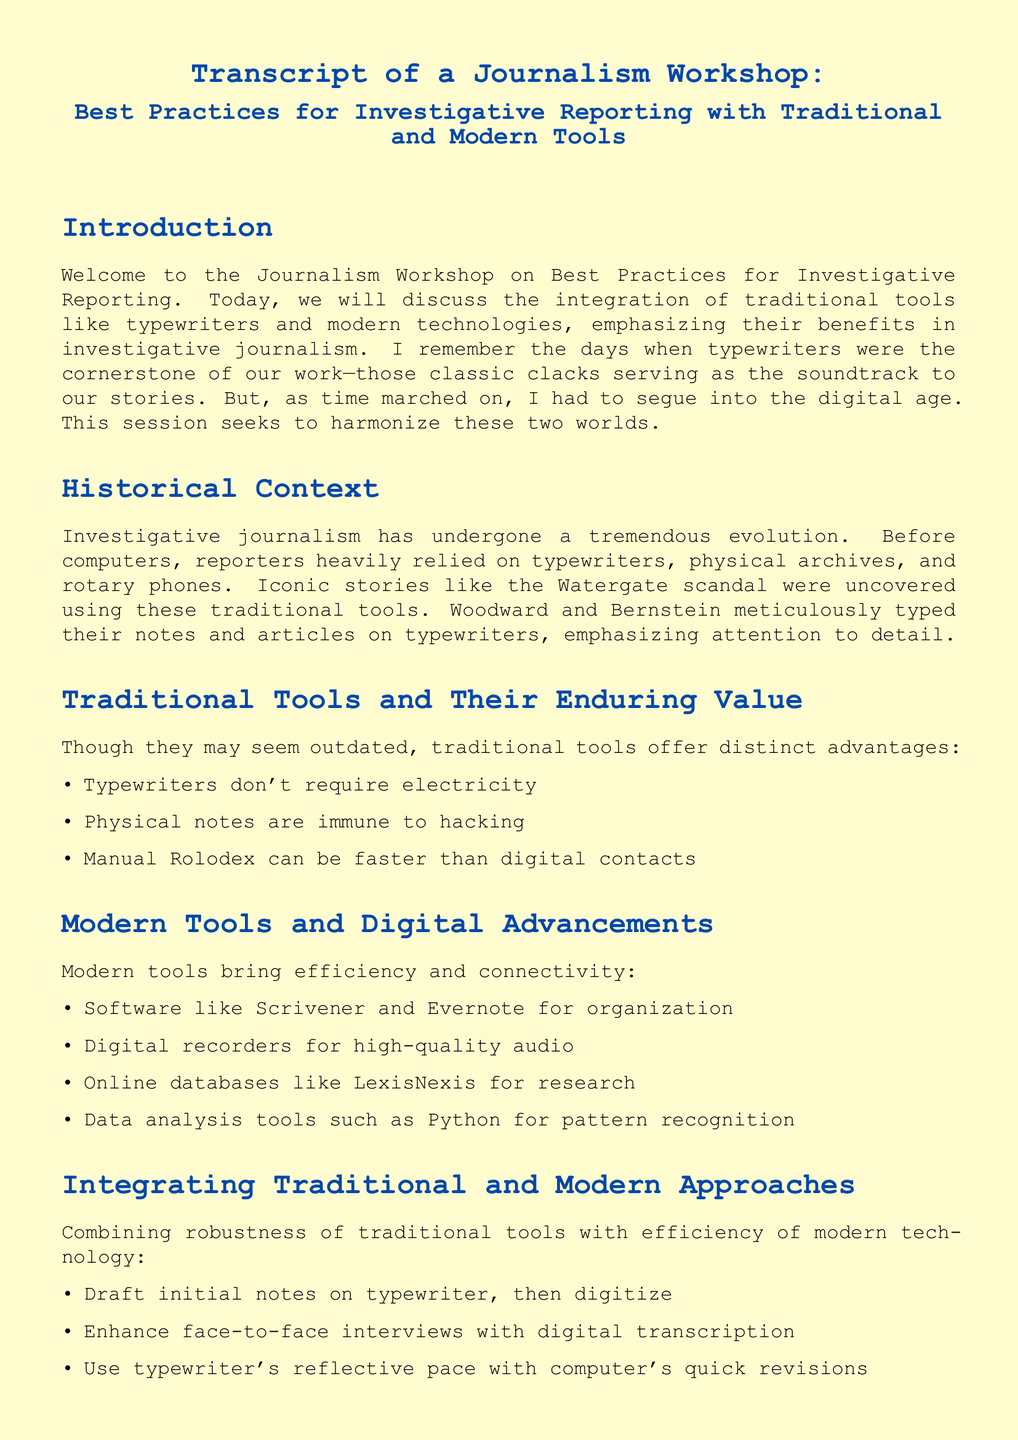What is the title of the workshop? The title of the workshop is mentioned in the document's header, combining the focus of the session on investigative reporting practices.
Answer: Best Practices for Investigative Reporting with Traditional and Modern Tools Who were the iconic reporters mentioned in the historical context? The document refers to well-known journalists who performed significant investigative reporting, particularly notable for the Watergate scandal.
Answer: Woodward and Bernstein What is one advantage of using typewriters according to the document? The document lists benefits of traditional tools, particularly highlighting aspects of typewriter use.
Answer: Don't require electricity What modern tool is mentioned for organizing notes? The document includes a list of modern tools highlighting their functionalities, specifically for organization.
Answer: Scrivener What does the document suggest as a method to integrate traditional and modern tools? The document details strategies for blending traditional methods with modern technology, emphasizing their combined strengths.
Answer: Draft initial notes on typewriter, then digitize What emotion does the author express about typewriters? The author reflects an emotional sentiment towards an old technology that significantly impacted journalism for him, revealing deeper values associated with their use.
Answer: Virtues How many distinct sections are there in the document? The document is structured into several clear headers indicating different topics within the workshop, allowing for organized presentation.
Answer: Six 